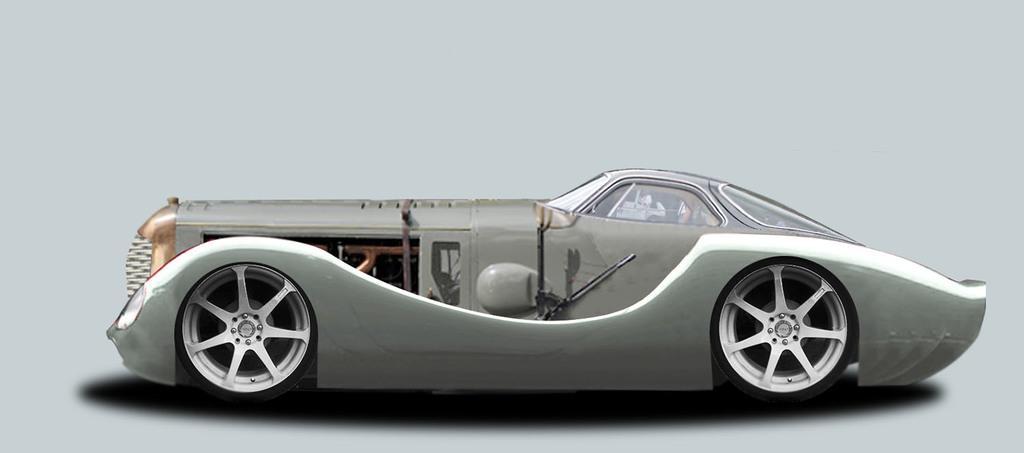In one or two sentences, can you explain what this image depicts? In the picture we can see a side view of the car with window glasses and wheels and the car is gray in color. 